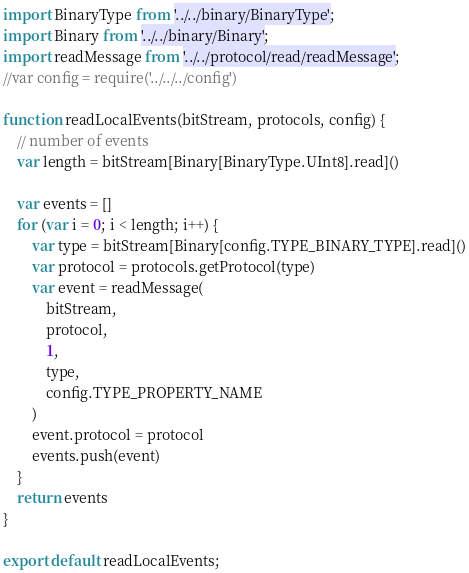Convert code to text. <code><loc_0><loc_0><loc_500><loc_500><_JavaScript_>import BinaryType from '../../binary/BinaryType';
import Binary from '../../binary/Binary';
import readMessage from '../../protocol/read/readMessage';
//var config = require('../../../config')

function readLocalEvents(bitStream, protocols, config) {
    // number of events
    var length = bitStream[Binary[BinaryType.UInt8].read]()

    var events = []
    for (var i = 0; i < length; i++) {
        var type = bitStream[Binary[config.TYPE_BINARY_TYPE].read]()
        var protocol = protocols.getProtocol(type)
        var event = readMessage(
            bitStream, 
            protocol, 
            1, 
            type, 
            config.TYPE_PROPERTY_NAME
        )
        event.protocol = protocol
        events.push(event)
    }
    return events    
}

export default readLocalEvents;</code> 